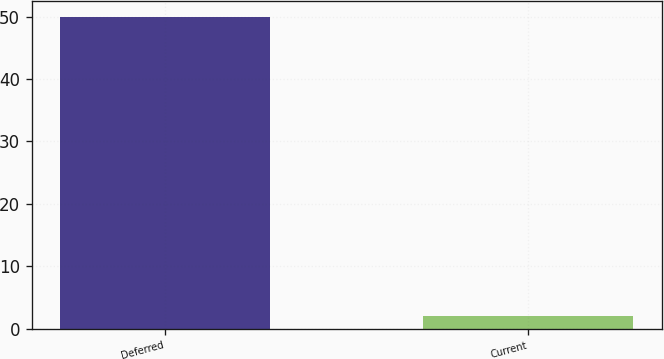Convert chart. <chart><loc_0><loc_0><loc_500><loc_500><bar_chart><fcel>Deferred<fcel>Current<nl><fcel>50<fcel>2<nl></chart> 